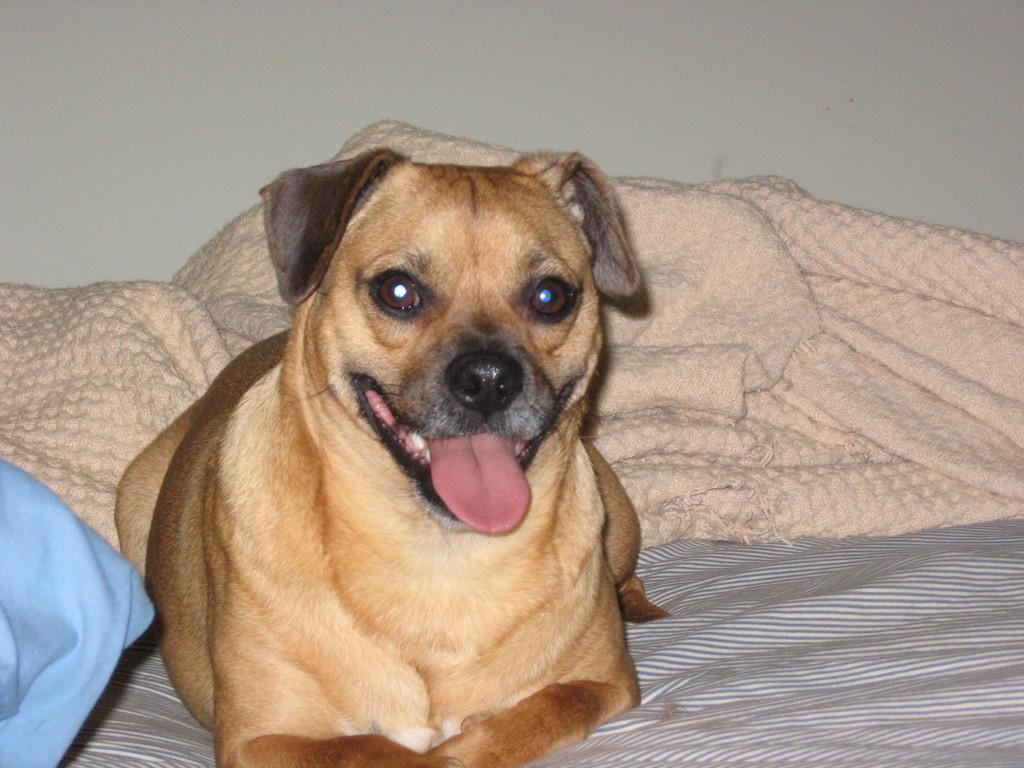Describe this image in one or two sentences. In this image we can see a dog which is brown in color is resting on bed and in the background of the image there is blanket which is in cream color and there is a wall. 